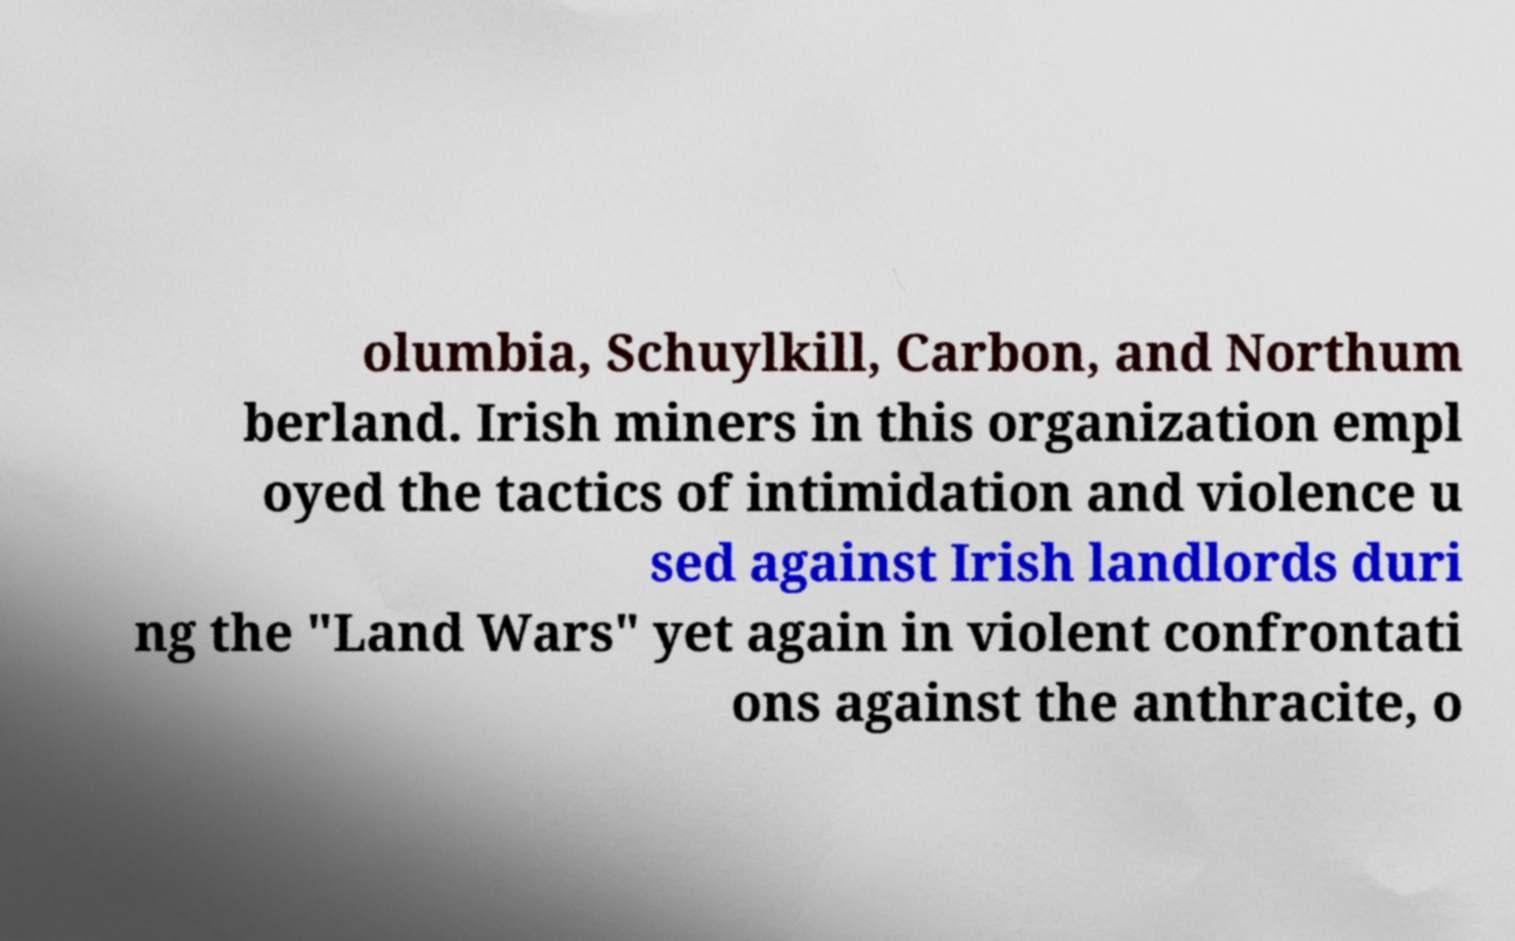Please identify and transcribe the text found in this image. olumbia, Schuylkill, Carbon, and Northum berland. Irish miners in this organization empl oyed the tactics of intimidation and violence u sed against Irish landlords duri ng the "Land Wars" yet again in violent confrontati ons against the anthracite, o 